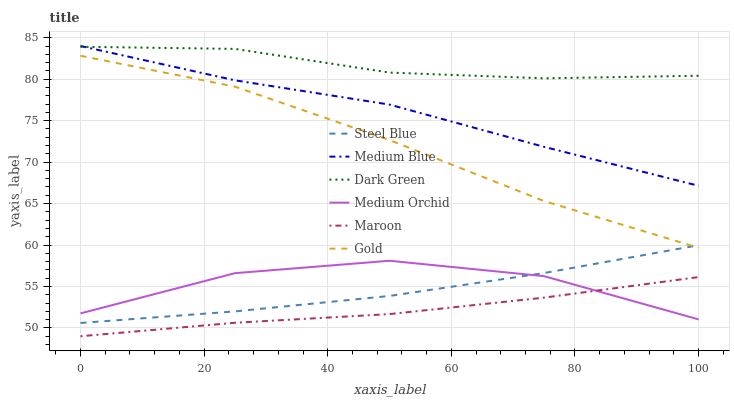Does Maroon have the minimum area under the curve?
Answer yes or no. Yes. Does Dark Green have the maximum area under the curve?
Answer yes or no. Yes. Does Medium Orchid have the minimum area under the curve?
Answer yes or no. No. Does Medium Orchid have the maximum area under the curve?
Answer yes or no. No. Is Steel Blue the smoothest?
Answer yes or no. Yes. Is Medium Orchid the roughest?
Answer yes or no. Yes. Is Medium Blue the smoothest?
Answer yes or no. No. Is Medium Blue the roughest?
Answer yes or no. No. Does Maroon have the lowest value?
Answer yes or no. Yes. Does Medium Orchid have the lowest value?
Answer yes or no. No. Does Medium Blue have the highest value?
Answer yes or no. Yes. Does Medium Orchid have the highest value?
Answer yes or no. No. Is Gold less than Dark Green?
Answer yes or no. Yes. Is Dark Green greater than Maroon?
Answer yes or no. Yes. Does Maroon intersect Medium Orchid?
Answer yes or no. Yes. Is Maroon less than Medium Orchid?
Answer yes or no. No. Is Maroon greater than Medium Orchid?
Answer yes or no. No. Does Gold intersect Dark Green?
Answer yes or no. No. 